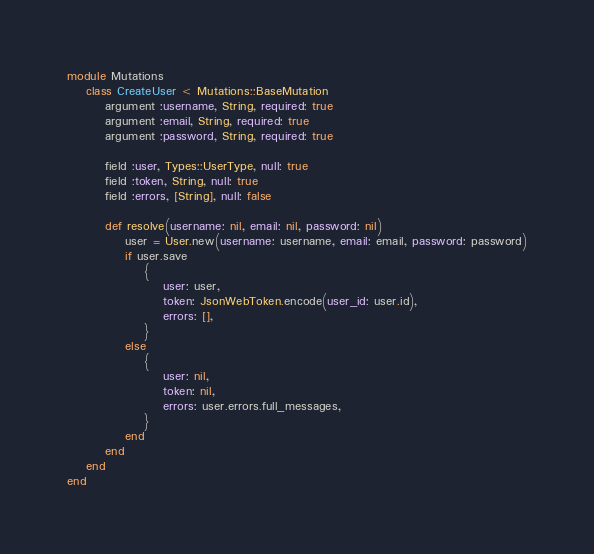<code> <loc_0><loc_0><loc_500><loc_500><_Ruby_>module Mutations
	class CreateUser < Mutations::BaseMutation
		argument :username, String, required: true
		argument :email, String, required: true
		argument :password, String, required: true

		field :user, Types::UserType, null: true
		field :token, String, null: true
		field :errors, [String], null: false

		def resolve(username: nil, email: nil, password: nil)
			user = User.new(username: username, email: email, password: password)
			if user.save
				{
					user: user,
					token: JsonWebToken.encode(user_id: user.id),
					errors: [],
				}
			else
				{
					user: nil,
					token: nil,
					errors: user.errors.full_messages,
				}
			end
		end
	end
end</code> 